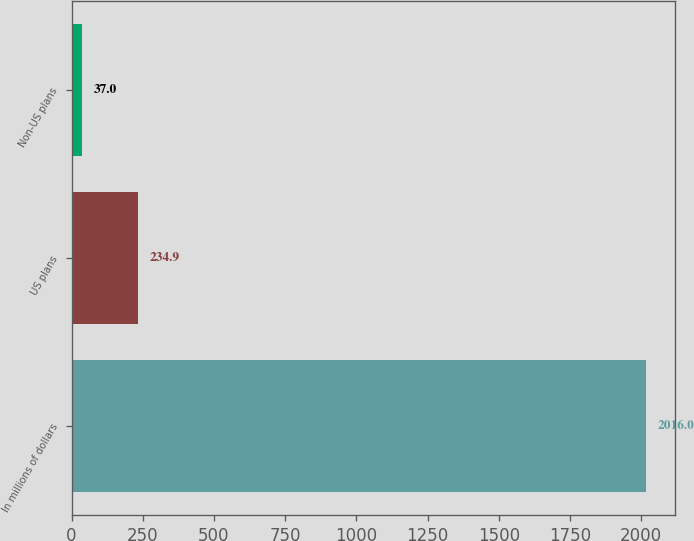Convert chart. <chart><loc_0><loc_0><loc_500><loc_500><bar_chart><fcel>In millions of dollars<fcel>US plans<fcel>Non-US plans<nl><fcel>2016<fcel>234.9<fcel>37<nl></chart> 